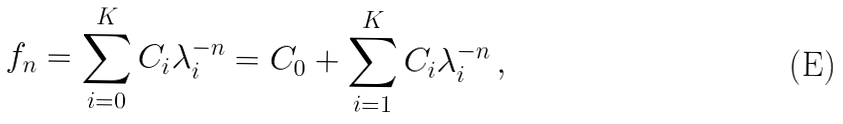Convert formula to latex. <formula><loc_0><loc_0><loc_500><loc_500>f _ { n } = \sum _ { i = 0 } ^ { K } C _ { i } \lambda _ { i } ^ { - n } = C _ { 0 } + \sum _ { i = 1 } ^ { K } C _ { i } \lambda _ { i } ^ { - n } \, ,</formula> 